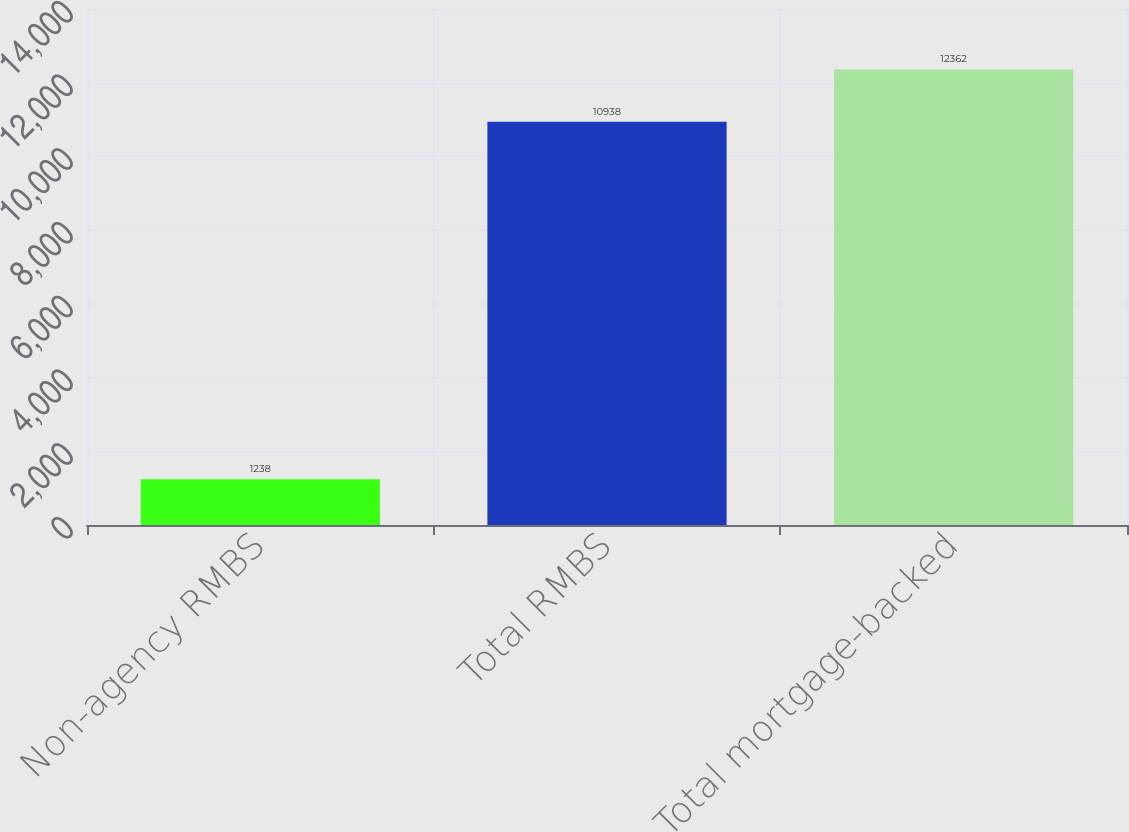<chart> <loc_0><loc_0><loc_500><loc_500><bar_chart><fcel>Non-agency RMBS<fcel>Total RMBS<fcel>Total mortgage-backed<nl><fcel>1238<fcel>10938<fcel>12362<nl></chart> 